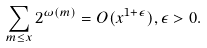Convert formula to latex. <formula><loc_0><loc_0><loc_500><loc_500>\sum _ { m \leq x } 2 ^ { \omega ( m ) } = O ( x ^ { 1 + \epsilon } ) , \epsilon > 0 .</formula> 